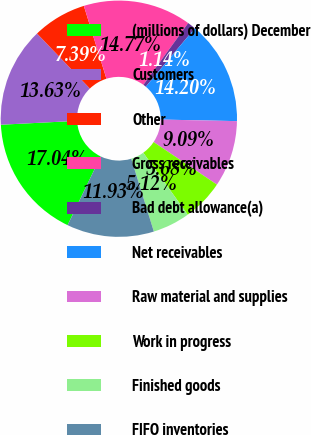<chart> <loc_0><loc_0><loc_500><loc_500><pie_chart><fcel>(millions of dollars) December<fcel>Customers<fcel>Other<fcel>Gross receivables<fcel>Bad debt allowance(a)<fcel>Net receivables<fcel>Raw material and supplies<fcel>Work in progress<fcel>Finished goods<fcel>FIFO inventories<nl><fcel>17.04%<fcel>13.63%<fcel>7.39%<fcel>14.77%<fcel>1.14%<fcel>14.2%<fcel>9.09%<fcel>5.68%<fcel>5.12%<fcel>11.93%<nl></chart> 